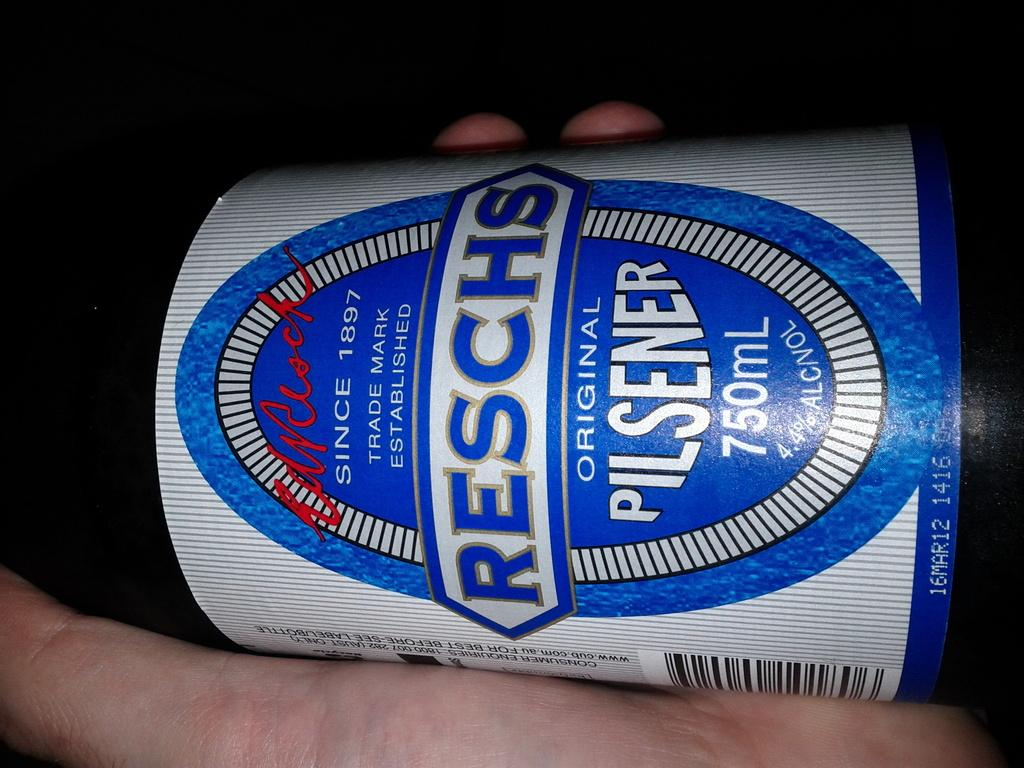<image>
Offer a succinct explanation of the picture presented. A hand holds a bottle of Reschs pilsener. 